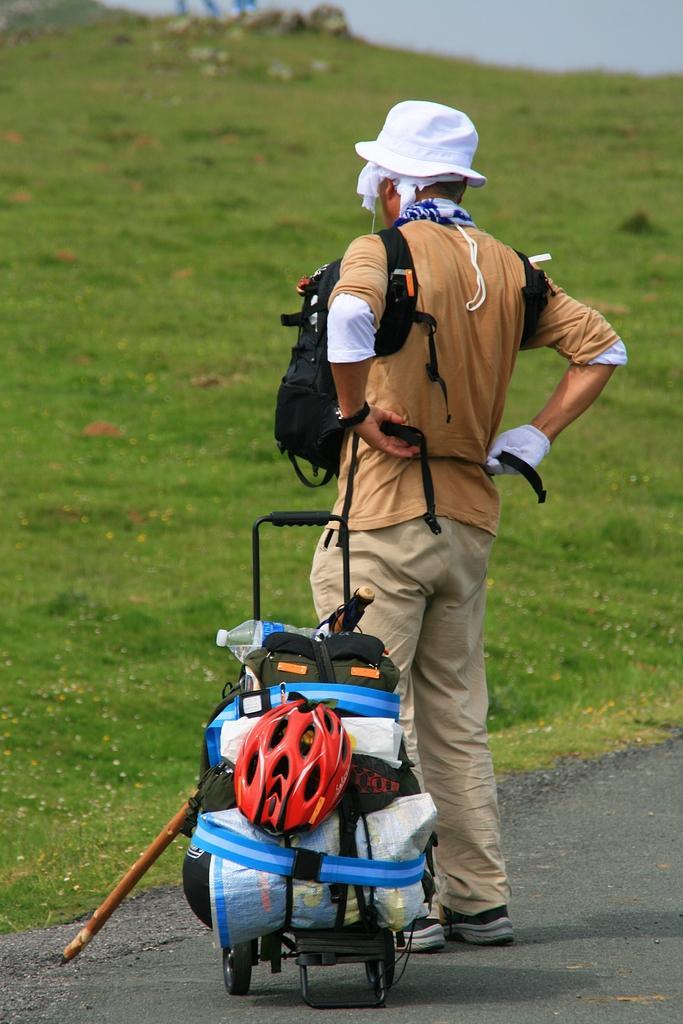How would you summarize this image in a sentence or two? As we can see in the image there is a grass and a man standing on road and beside him there is a suitcase. 